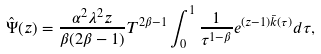<formula> <loc_0><loc_0><loc_500><loc_500>\hat { \Psi } ( z ) = \frac { \alpha ^ { 2 } \lambda ^ { 2 } z } { \beta ( 2 \beta - 1 ) } T ^ { 2 \beta - 1 } \int _ { 0 } ^ { 1 } \frac { 1 } { \tau ^ { 1 - \beta } } e ^ { ( z - 1 ) \bar { k } ( \tau ) } d \tau ,</formula> 